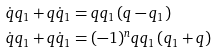<formula> <loc_0><loc_0><loc_500><loc_500>\dot { q } q _ { 1 } + q \dot { q } _ { 1 } & = q q _ { 1 } \left ( q - q _ { 1 } \right ) \\ \dot { q } q _ { 1 } + q \dot { q } _ { 1 } & = ( - 1 ) ^ { n } q q _ { 1 } \left ( q _ { 1 } + q \right )</formula> 